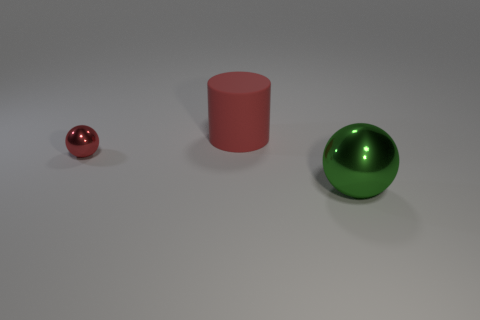What could be the possible materials of these three objects, based on their appearances? Based on the image, the materials seem to be as follows: The small red sphere has a reflective surface that suggests it might be made of polished metal. The red cylindrical object has a matte finish, indicating it could be made of a plastic or painted wood. Lastly, the green sphere has a shiny surface as well, which hints at it being made of glass or a polished semi-precious stone, like jade. 